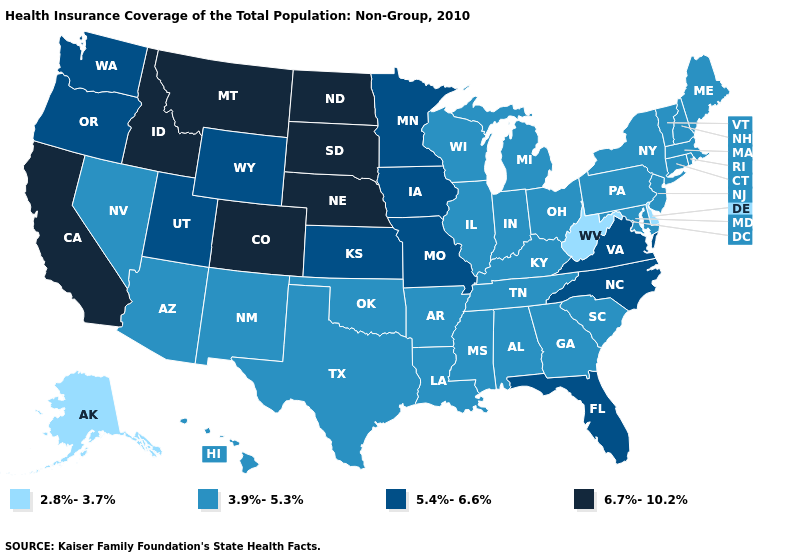Among the states that border South Dakota , which have the lowest value?
Be succinct. Iowa, Minnesota, Wyoming. Does California have the highest value in the USA?
Give a very brief answer. Yes. Does Wyoming have a higher value than Washington?
Concise answer only. No. Which states have the highest value in the USA?
Answer briefly. California, Colorado, Idaho, Montana, Nebraska, North Dakota, South Dakota. Does Illinois have the same value as Michigan?
Give a very brief answer. Yes. Does North Carolina have the lowest value in the USA?
Quick response, please. No. What is the highest value in states that border Arizona?
Give a very brief answer. 6.7%-10.2%. Does Arkansas have the highest value in the USA?
Give a very brief answer. No. Which states have the highest value in the USA?
Keep it brief. California, Colorado, Idaho, Montana, Nebraska, North Dakota, South Dakota. What is the value of Alaska?
Answer briefly. 2.8%-3.7%. Is the legend a continuous bar?
Be succinct. No. Name the states that have a value in the range 6.7%-10.2%?
Write a very short answer. California, Colorado, Idaho, Montana, Nebraska, North Dakota, South Dakota. What is the highest value in the Northeast ?
Answer briefly. 3.9%-5.3%. Which states have the highest value in the USA?
Concise answer only. California, Colorado, Idaho, Montana, Nebraska, North Dakota, South Dakota. What is the value of Maryland?
Give a very brief answer. 3.9%-5.3%. 